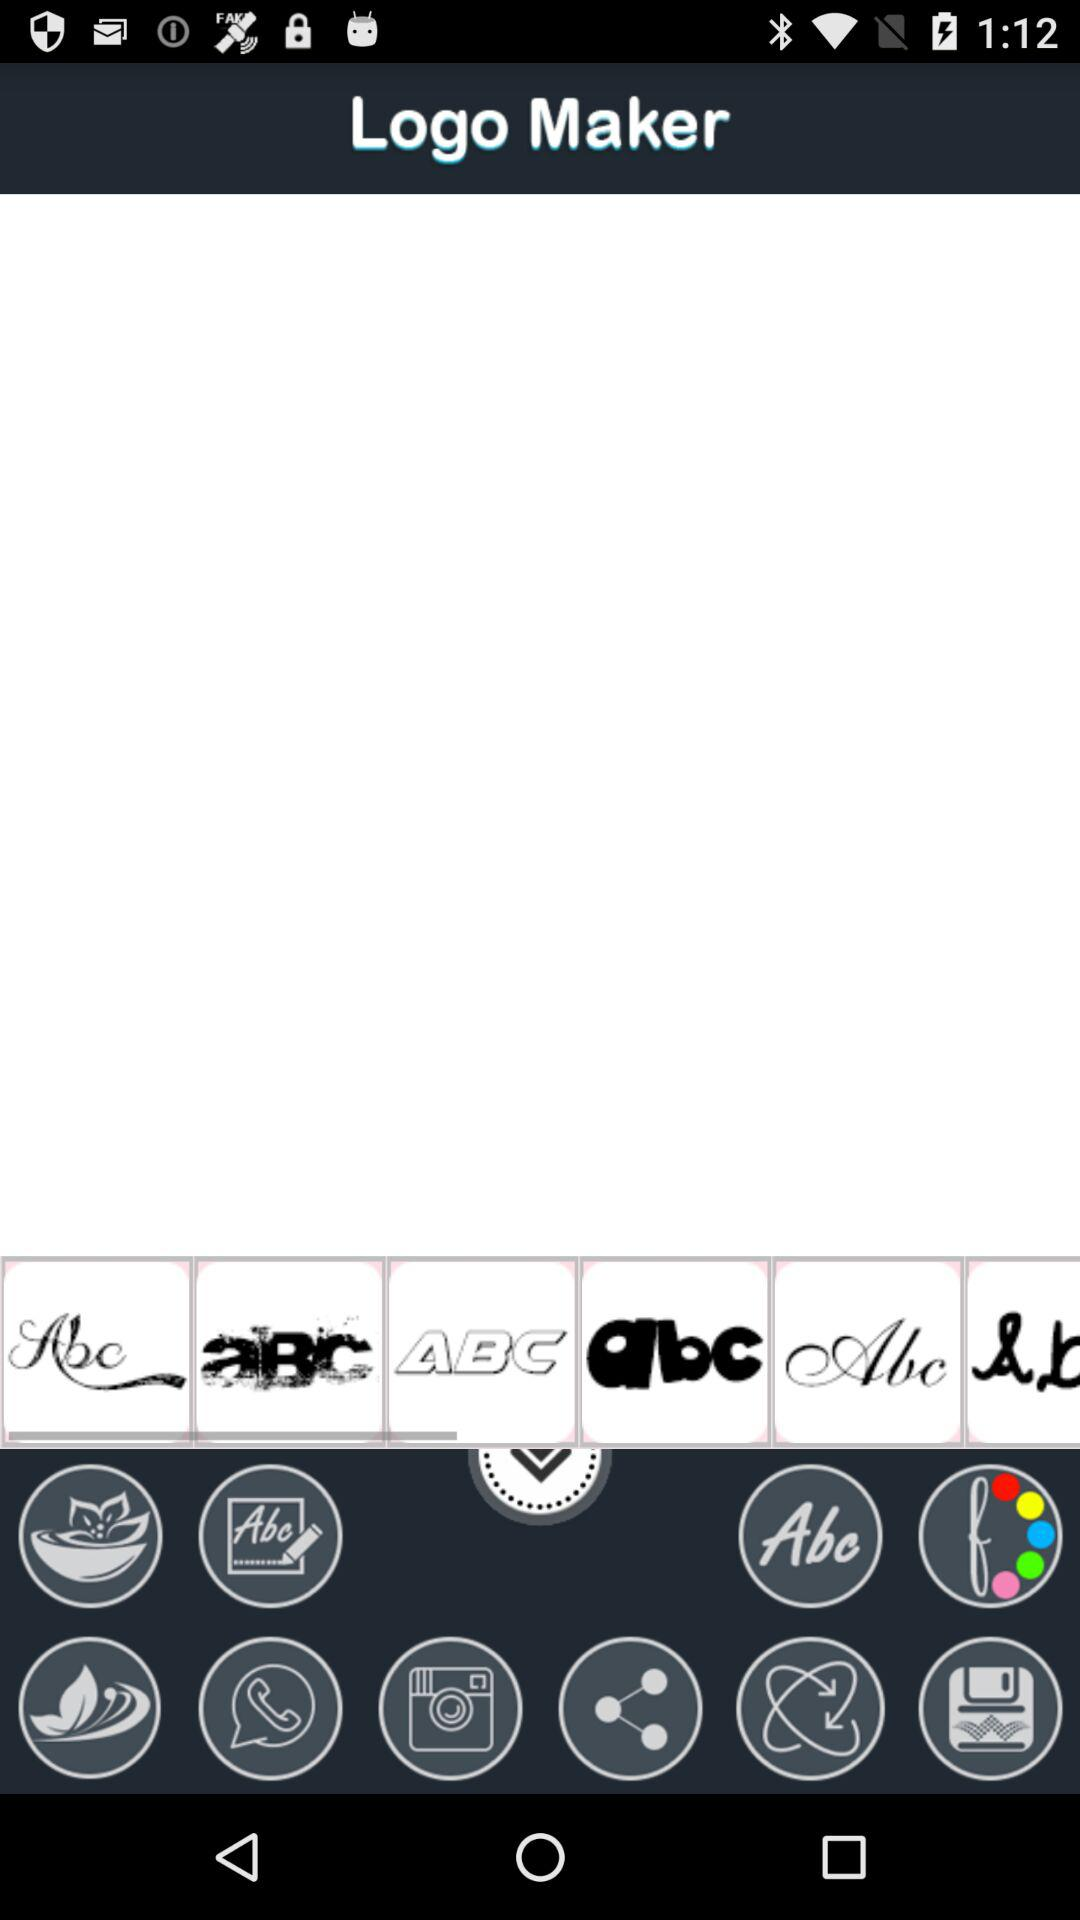How many new applications are there? There is 1 new application. 